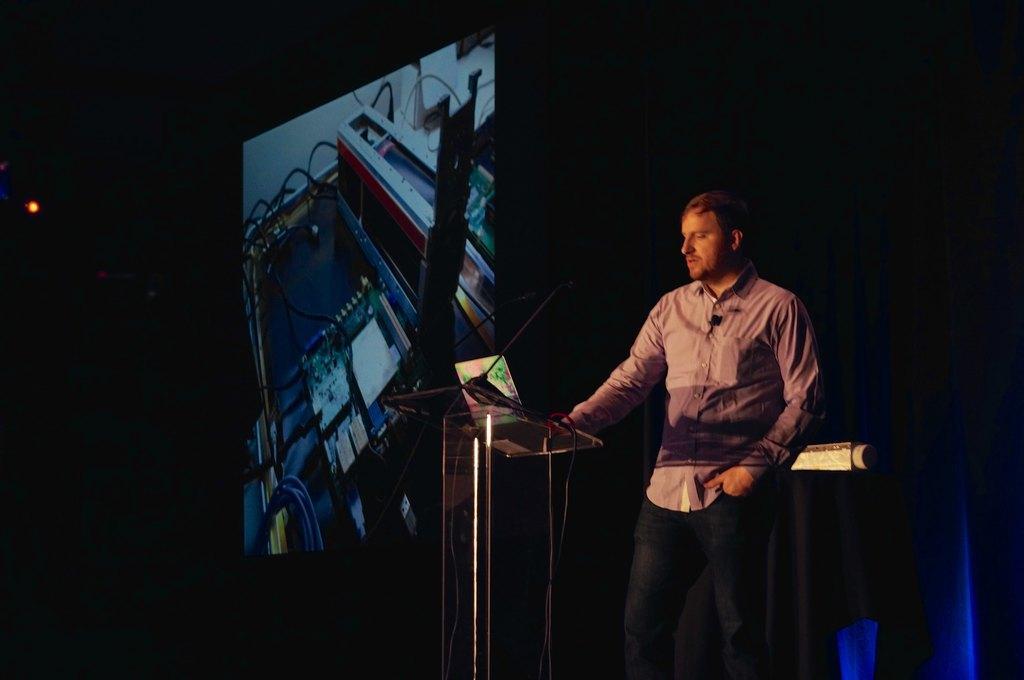Please provide a concise description of this image. In this image I can see a man is standing on the right side and in the front of him I can see a podium. On the podium I can see few mics and a laptop. In the background I can see a screen, blue curtain and on the left side of this image I can see a light. 